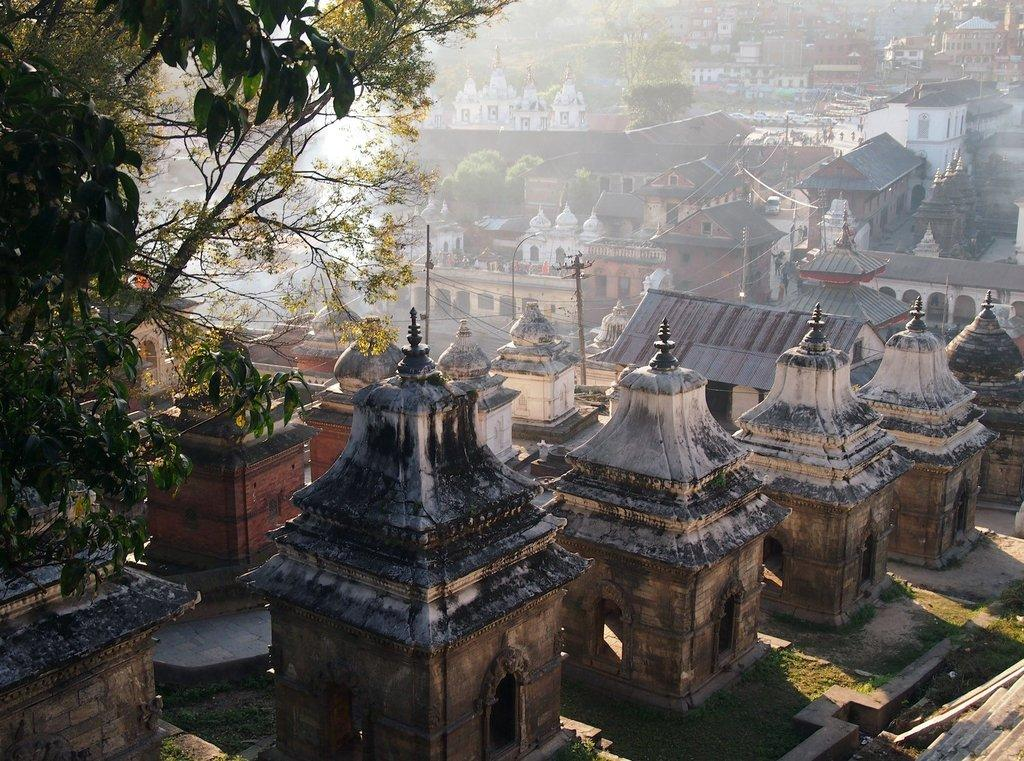What type of structures can be seen in the image? There are houses in the image. What type of vegetation is at the bottom of the image? There is grass at the bottom of the image. Where is the tree located in the image? The tree is on the left side of the image. What are the tall, thin objects visible in the image? There are poles visible in the image. What other type of vegetation can be seen in the image? There are trees in the middle of the image. Can you hear the whistle of the wind blowing through the canvas in the image? There is no mention of a whistle or canvas in the image, so we cannot hear or see them. 